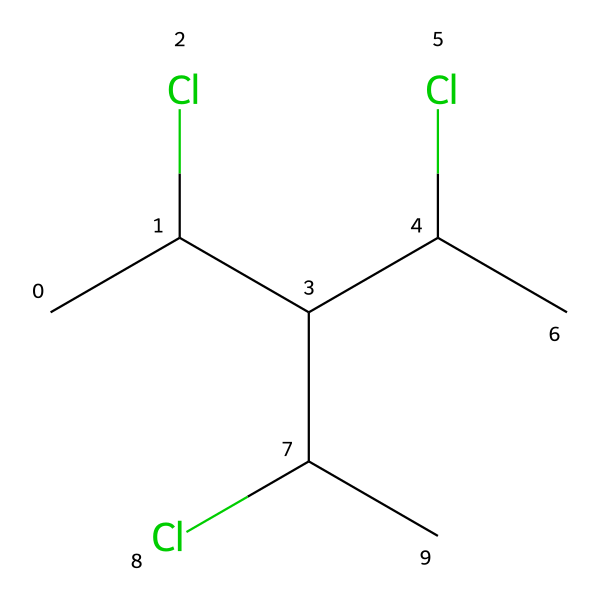What is the name of the polymer represented in the SMILES? The SMILES representation shows a structure of polyvinyl chloride (PVC), which is a commonly used plastic. The presence of repeating units with carbon, chlorine, and hydrogen indicates it is a chlorinated polymer.
Answer: polyvinyl chloride How many chlorine atoms are present in the molecule? By analyzing the SMILES, we can count the 'Cl' notations, which indicate there are four chlorine atoms attached to the carbon backbone.
Answer: four What is the total number of carbon atoms in the structure? The SMILES shows each ‘C’ represents a carbon atom. By counting all the occurrences of 'C' in the SMILES notation, we find there are six carbon atoms in this polyvinyl chloride structure.
Answer: six What type of bonds are primarily found in polyvinyl chloride? Polyvinyl chloride mainly consists of single covalent bonds connecting carbon atoms and between carbon and chlorine atoms. This is evident from the structure that displays the connectivity between the atoms.
Answer: single bonds Is this polymer considered thermoplastic or thermosetting? Polyvinyl chloride is categorized as a thermoplastic because it softens upon heating and can be reshaped, which is inherent to its molecular structure.
Answer: thermoplastic What role does chlorine play in the properties of this polymer? The presence of chlorine in the polymer structure contributes to its polarity and increases flame resistance, chemical resistance, and durability. This can be inferred from the multiple chlorine substitutions on the carbon chain, which modify the polymer's properties.
Answer: enhances durability 